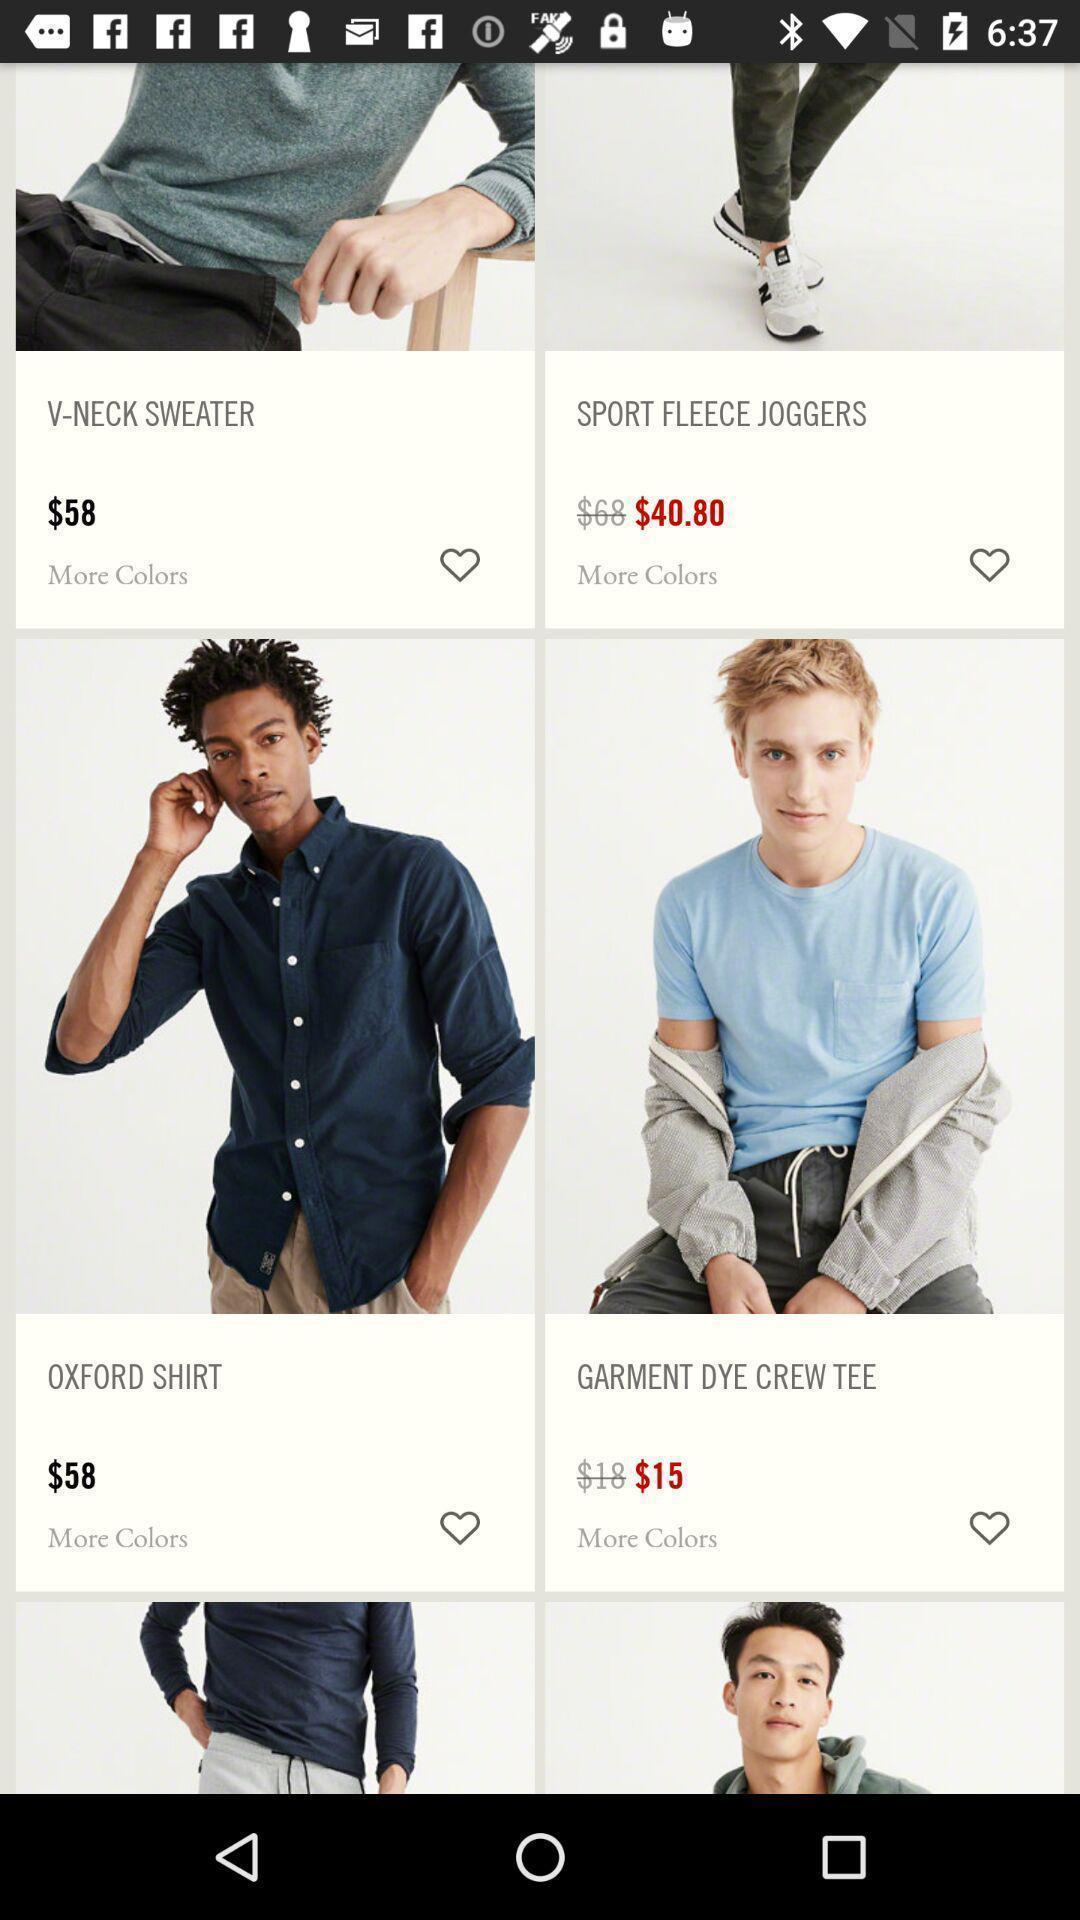Give me a summary of this screen capture. Screen showing page of an shopping application. 